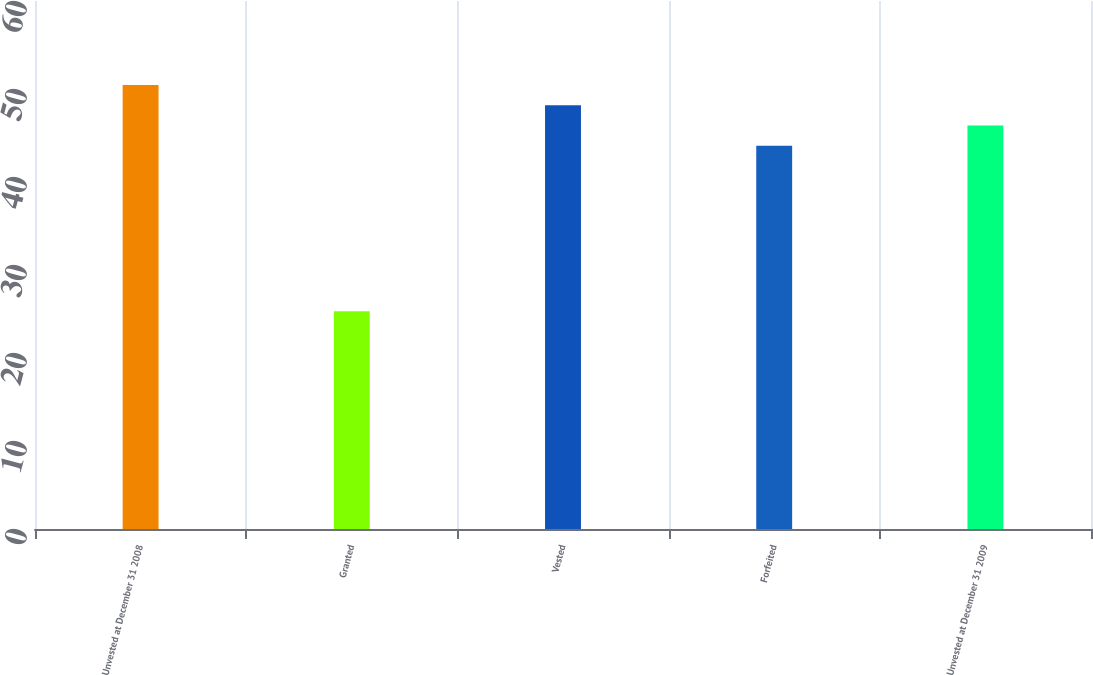Convert chart. <chart><loc_0><loc_0><loc_500><loc_500><bar_chart><fcel>Unvested at December 31 2008<fcel>Granted<fcel>Vested<fcel>Forfeited<fcel>Unvested at December 31 2009<nl><fcel>50.46<fcel>24.74<fcel>48.16<fcel>43.56<fcel>45.86<nl></chart> 